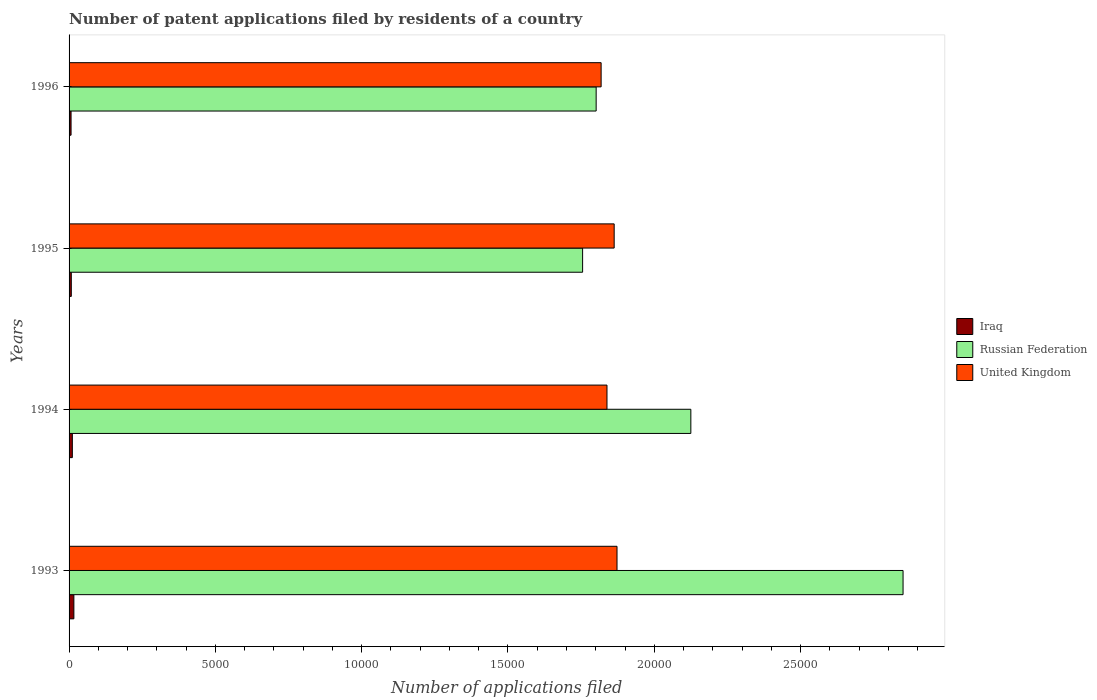Are the number of bars on each tick of the Y-axis equal?
Keep it short and to the point. Yes. How many bars are there on the 2nd tick from the bottom?
Offer a very short reply. 3. In how many cases, is the number of bars for a given year not equal to the number of legend labels?
Your answer should be very brief. 0. What is the number of applications filed in Russian Federation in 1996?
Ensure brevity in your answer.  1.80e+04. Across all years, what is the maximum number of applications filed in Russian Federation?
Provide a short and direct response. 2.85e+04. Across all years, what is the minimum number of applications filed in United Kingdom?
Your response must be concise. 1.82e+04. In which year was the number of applications filed in Russian Federation maximum?
Provide a short and direct response. 1993. In which year was the number of applications filed in United Kingdom minimum?
Your response must be concise. 1996. What is the total number of applications filed in United Kingdom in the graph?
Keep it short and to the point. 7.39e+04. What is the difference between the number of applications filed in Russian Federation in 1994 and the number of applications filed in Iraq in 1993?
Your answer should be compact. 2.11e+04. What is the average number of applications filed in Iraq per year?
Your answer should be very brief. 105. In the year 1994, what is the difference between the number of applications filed in Iraq and number of applications filed in Russian Federation?
Keep it short and to the point. -2.11e+04. In how many years, is the number of applications filed in Russian Federation greater than 4000 ?
Provide a succinct answer. 4. What is the ratio of the number of applications filed in Iraq in 1994 to that in 1995?
Your answer should be very brief. 1.47. What is the difference between the highest and the second highest number of applications filed in United Kingdom?
Your answer should be very brief. 97. What is the difference between the highest and the lowest number of applications filed in Iraq?
Keep it short and to the point. 96. Is the sum of the number of applications filed in Iraq in 1993 and 1995 greater than the maximum number of applications filed in United Kingdom across all years?
Your response must be concise. No. What does the 1st bar from the bottom in 1993 represents?
Provide a short and direct response. Iraq. Are the values on the major ticks of X-axis written in scientific E-notation?
Your answer should be compact. No. Does the graph contain grids?
Give a very brief answer. No. How many legend labels are there?
Keep it short and to the point. 3. How are the legend labels stacked?
Offer a terse response. Vertical. What is the title of the graph?
Offer a very short reply. Number of patent applications filed by residents of a country. Does "Malta" appear as one of the legend labels in the graph?
Provide a short and direct response. No. What is the label or title of the X-axis?
Offer a terse response. Number of applications filed. What is the label or title of the Y-axis?
Keep it short and to the point. Years. What is the Number of applications filed of Iraq in 1993?
Keep it short and to the point. 164. What is the Number of applications filed in Russian Federation in 1993?
Ensure brevity in your answer.  2.85e+04. What is the Number of applications filed in United Kingdom in 1993?
Make the answer very short. 1.87e+04. What is the Number of applications filed of Iraq in 1994?
Offer a very short reply. 112. What is the Number of applications filed in Russian Federation in 1994?
Offer a very short reply. 2.12e+04. What is the Number of applications filed of United Kingdom in 1994?
Your answer should be very brief. 1.84e+04. What is the Number of applications filed in Iraq in 1995?
Ensure brevity in your answer.  76. What is the Number of applications filed in Russian Federation in 1995?
Keep it short and to the point. 1.76e+04. What is the Number of applications filed in United Kingdom in 1995?
Your answer should be very brief. 1.86e+04. What is the Number of applications filed of Iraq in 1996?
Provide a short and direct response. 68. What is the Number of applications filed of Russian Federation in 1996?
Keep it short and to the point. 1.80e+04. What is the Number of applications filed in United Kingdom in 1996?
Give a very brief answer. 1.82e+04. Across all years, what is the maximum Number of applications filed of Iraq?
Give a very brief answer. 164. Across all years, what is the maximum Number of applications filed in Russian Federation?
Your answer should be very brief. 2.85e+04. Across all years, what is the maximum Number of applications filed of United Kingdom?
Your response must be concise. 1.87e+04. Across all years, what is the minimum Number of applications filed in Russian Federation?
Provide a succinct answer. 1.76e+04. Across all years, what is the minimum Number of applications filed in United Kingdom?
Make the answer very short. 1.82e+04. What is the total Number of applications filed of Iraq in the graph?
Offer a very short reply. 420. What is the total Number of applications filed of Russian Federation in the graph?
Offer a very short reply. 8.53e+04. What is the total Number of applications filed in United Kingdom in the graph?
Give a very brief answer. 7.39e+04. What is the difference between the Number of applications filed of Russian Federation in 1993 and that in 1994?
Ensure brevity in your answer.  7253. What is the difference between the Number of applications filed in United Kingdom in 1993 and that in 1994?
Your answer should be very brief. 343. What is the difference between the Number of applications filed in Russian Federation in 1993 and that in 1995?
Your response must be concise. 1.10e+04. What is the difference between the Number of applications filed of United Kingdom in 1993 and that in 1995?
Your response must be concise. 97. What is the difference between the Number of applications filed of Iraq in 1993 and that in 1996?
Ensure brevity in your answer.  96. What is the difference between the Number of applications filed in Russian Federation in 1993 and that in 1996?
Provide a short and direct response. 1.05e+04. What is the difference between the Number of applications filed in United Kingdom in 1993 and that in 1996?
Make the answer very short. 543. What is the difference between the Number of applications filed of Iraq in 1994 and that in 1995?
Keep it short and to the point. 36. What is the difference between the Number of applications filed of Russian Federation in 1994 and that in 1995?
Provide a short and direct response. 3699. What is the difference between the Number of applications filed in United Kingdom in 1994 and that in 1995?
Ensure brevity in your answer.  -246. What is the difference between the Number of applications filed in Russian Federation in 1994 and that in 1996?
Your answer should be very brief. 3236. What is the difference between the Number of applications filed of Russian Federation in 1995 and that in 1996?
Make the answer very short. -463. What is the difference between the Number of applications filed in United Kingdom in 1995 and that in 1996?
Your answer should be very brief. 446. What is the difference between the Number of applications filed in Iraq in 1993 and the Number of applications filed in Russian Federation in 1994?
Provide a succinct answer. -2.11e+04. What is the difference between the Number of applications filed in Iraq in 1993 and the Number of applications filed in United Kingdom in 1994?
Give a very brief answer. -1.82e+04. What is the difference between the Number of applications filed of Russian Federation in 1993 and the Number of applications filed of United Kingdom in 1994?
Offer a terse response. 1.01e+04. What is the difference between the Number of applications filed in Iraq in 1993 and the Number of applications filed in Russian Federation in 1995?
Make the answer very short. -1.74e+04. What is the difference between the Number of applications filed of Iraq in 1993 and the Number of applications filed of United Kingdom in 1995?
Ensure brevity in your answer.  -1.85e+04. What is the difference between the Number of applications filed of Russian Federation in 1993 and the Number of applications filed of United Kingdom in 1995?
Provide a succinct answer. 9873. What is the difference between the Number of applications filed in Iraq in 1993 and the Number of applications filed in Russian Federation in 1996?
Give a very brief answer. -1.78e+04. What is the difference between the Number of applications filed in Iraq in 1993 and the Number of applications filed in United Kingdom in 1996?
Offer a terse response. -1.80e+04. What is the difference between the Number of applications filed of Russian Federation in 1993 and the Number of applications filed of United Kingdom in 1996?
Ensure brevity in your answer.  1.03e+04. What is the difference between the Number of applications filed in Iraq in 1994 and the Number of applications filed in Russian Federation in 1995?
Give a very brief answer. -1.74e+04. What is the difference between the Number of applications filed in Iraq in 1994 and the Number of applications filed in United Kingdom in 1995?
Give a very brief answer. -1.85e+04. What is the difference between the Number of applications filed of Russian Federation in 1994 and the Number of applications filed of United Kingdom in 1995?
Your answer should be compact. 2620. What is the difference between the Number of applications filed of Iraq in 1994 and the Number of applications filed of Russian Federation in 1996?
Give a very brief answer. -1.79e+04. What is the difference between the Number of applications filed of Iraq in 1994 and the Number of applications filed of United Kingdom in 1996?
Ensure brevity in your answer.  -1.81e+04. What is the difference between the Number of applications filed in Russian Federation in 1994 and the Number of applications filed in United Kingdom in 1996?
Your answer should be very brief. 3066. What is the difference between the Number of applications filed of Iraq in 1995 and the Number of applications filed of Russian Federation in 1996?
Provide a short and direct response. -1.79e+04. What is the difference between the Number of applications filed of Iraq in 1995 and the Number of applications filed of United Kingdom in 1996?
Keep it short and to the point. -1.81e+04. What is the difference between the Number of applications filed in Russian Federation in 1995 and the Number of applications filed in United Kingdom in 1996?
Your answer should be very brief. -633. What is the average Number of applications filed of Iraq per year?
Give a very brief answer. 105. What is the average Number of applications filed of Russian Federation per year?
Provide a succinct answer. 2.13e+04. What is the average Number of applications filed of United Kingdom per year?
Keep it short and to the point. 1.85e+04. In the year 1993, what is the difference between the Number of applications filed in Iraq and Number of applications filed in Russian Federation?
Your answer should be very brief. -2.83e+04. In the year 1993, what is the difference between the Number of applications filed in Iraq and Number of applications filed in United Kingdom?
Offer a very short reply. -1.86e+04. In the year 1993, what is the difference between the Number of applications filed of Russian Federation and Number of applications filed of United Kingdom?
Your answer should be compact. 9776. In the year 1994, what is the difference between the Number of applications filed in Iraq and Number of applications filed in Russian Federation?
Provide a short and direct response. -2.11e+04. In the year 1994, what is the difference between the Number of applications filed of Iraq and Number of applications filed of United Kingdom?
Ensure brevity in your answer.  -1.83e+04. In the year 1994, what is the difference between the Number of applications filed in Russian Federation and Number of applications filed in United Kingdom?
Make the answer very short. 2866. In the year 1995, what is the difference between the Number of applications filed in Iraq and Number of applications filed in Russian Federation?
Offer a very short reply. -1.75e+04. In the year 1995, what is the difference between the Number of applications filed of Iraq and Number of applications filed of United Kingdom?
Your answer should be compact. -1.86e+04. In the year 1995, what is the difference between the Number of applications filed in Russian Federation and Number of applications filed in United Kingdom?
Offer a very short reply. -1079. In the year 1996, what is the difference between the Number of applications filed in Iraq and Number of applications filed in Russian Federation?
Keep it short and to the point. -1.79e+04. In the year 1996, what is the difference between the Number of applications filed in Iraq and Number of applications filed in United Kingdom?
Your answer should be very brief. -1.81e+04. In the year 1996, what is the difference between the Number of applications filed of Russian Federation and Number of applications filed of United Kingdom?
Keep it short and to the point. -170. What is the ratio of the Number of applications filed of Iraq in 1993 to that in 1994?
Provide a short and direct response. 1.46. What is the ratio of the Number of applications filed in Russian Federation in 1993 to that in 1994?
Offer a very short reply. 1.34. What is the ratio of the Number of applications filed in United Kingdom in 1993 to that in 1994?
Make the answer very short. 1.02. What is the ratio of the Number of applications filed of Iraq in 1993 to that in 1995?
Give a very brief answer. 2.16. What is the ratio of the Number of applications filed in Russian Federation in 1993 to that in 1995?
Your answer should be very brief. 1.62. What is the ratio of the Number of applications filed of Iraq in 1993 to that in 1996?
Offer a terse response. 2.41. What is the ratio of the Number of applications filed of Russian Federation in 1993 to that in 1996?
Offer a terse response. 1.58. What is the ratio of the Number of applications filed in United Kingdom in 1993 to that in 1996?
Provide a succinct answer. 1.03. What is the ratio of the Number of applications filed of Iraq in 1994 to that in 1995?
Give a very brief answer. 1.47. What is the ratio of the Number of applications filed of Russian Federation in 1994 to that in 1995?
Provide a short and direct response. 1.21. What is the ratio of the Number of applications filed of Iraq in 1994 to that in 1996?
Your response must be concise. 1.65. What is the ratio of the Number of applications filed of Russian Federation in 1994 to that in 1996?
Your answer should be compact. 1.18. What is the ratio of the Number of applications filed of United Kingdom in 1994 to that in 1996?
Your answer should be very brief. 1.01. What is the ratio of the Number of applications filed of Iraq in 1995 to that in 1996?
Provide a short and direct response. 1.12. What is the ratio of the Number of applications filed of Russian Federation in 1995 to that in 1996?
Provide a short and direct response. 0.97. What is the ratio of the Number of applications filed of United Kingdom in 1995 to that in 1996?
Ensure brevity in your answer.  1.02. What is the difference between the highest and the second highest Number of applications filed of Russian Federation?
Keep it short and to the point. 7253. What is the difference between the highest and the second highest Number of applications filed of United Kingdom?
Your response must be concise. 97. What is the difference between the highest and the lowest Number of applications filed of Iraq?
Provide a succinct answer. 96. What is the difference between the highest and the lowest Number of applications filed in Russian Federation?
Make the answer very short. 1.10e+04. What is the difference between the highest and the lowest Number of applications filed of United Kingdom?
Ensure brevity in your answer.  543. 